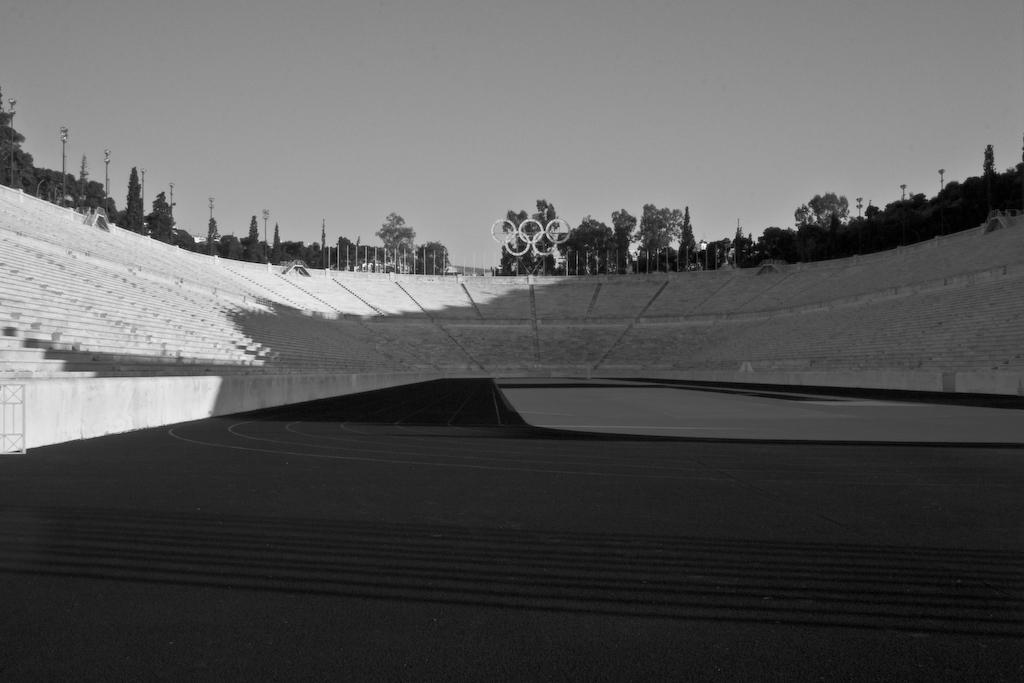What is the main structure visible in the image? There are strands of a stadium in the image. What can be seen in the background of the image? There are poles and trees on the ground in the background of the image. What part of the natural environment is visible in the image? The sky is visible in the image. What type of sign is being held by the slave in the image? There is no slave or sign present in the image. 